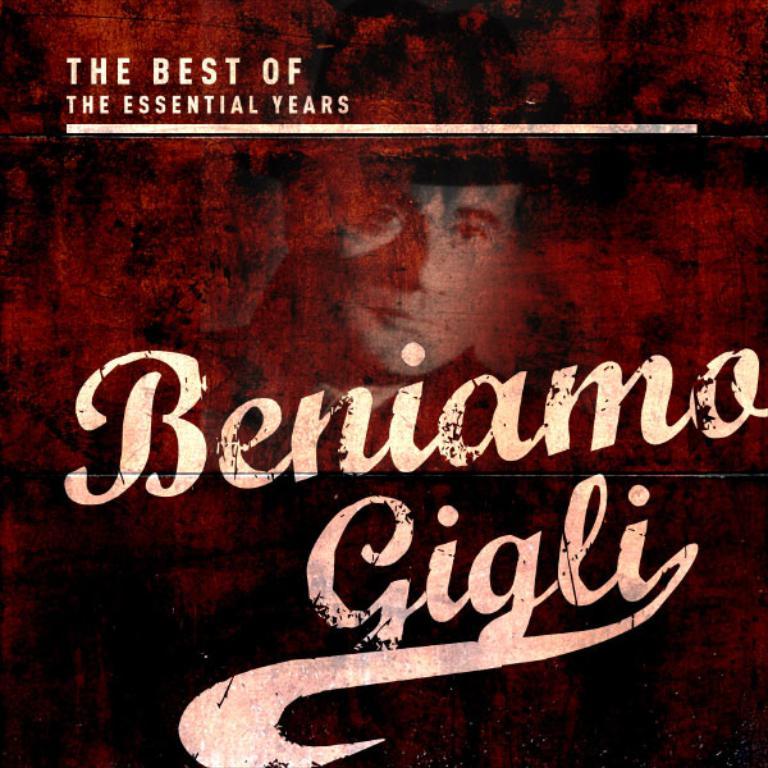The best of what?
Offer a terse response. The essential years. What is the title of this album?
Provide a short and direct response. The best of the essential years. 